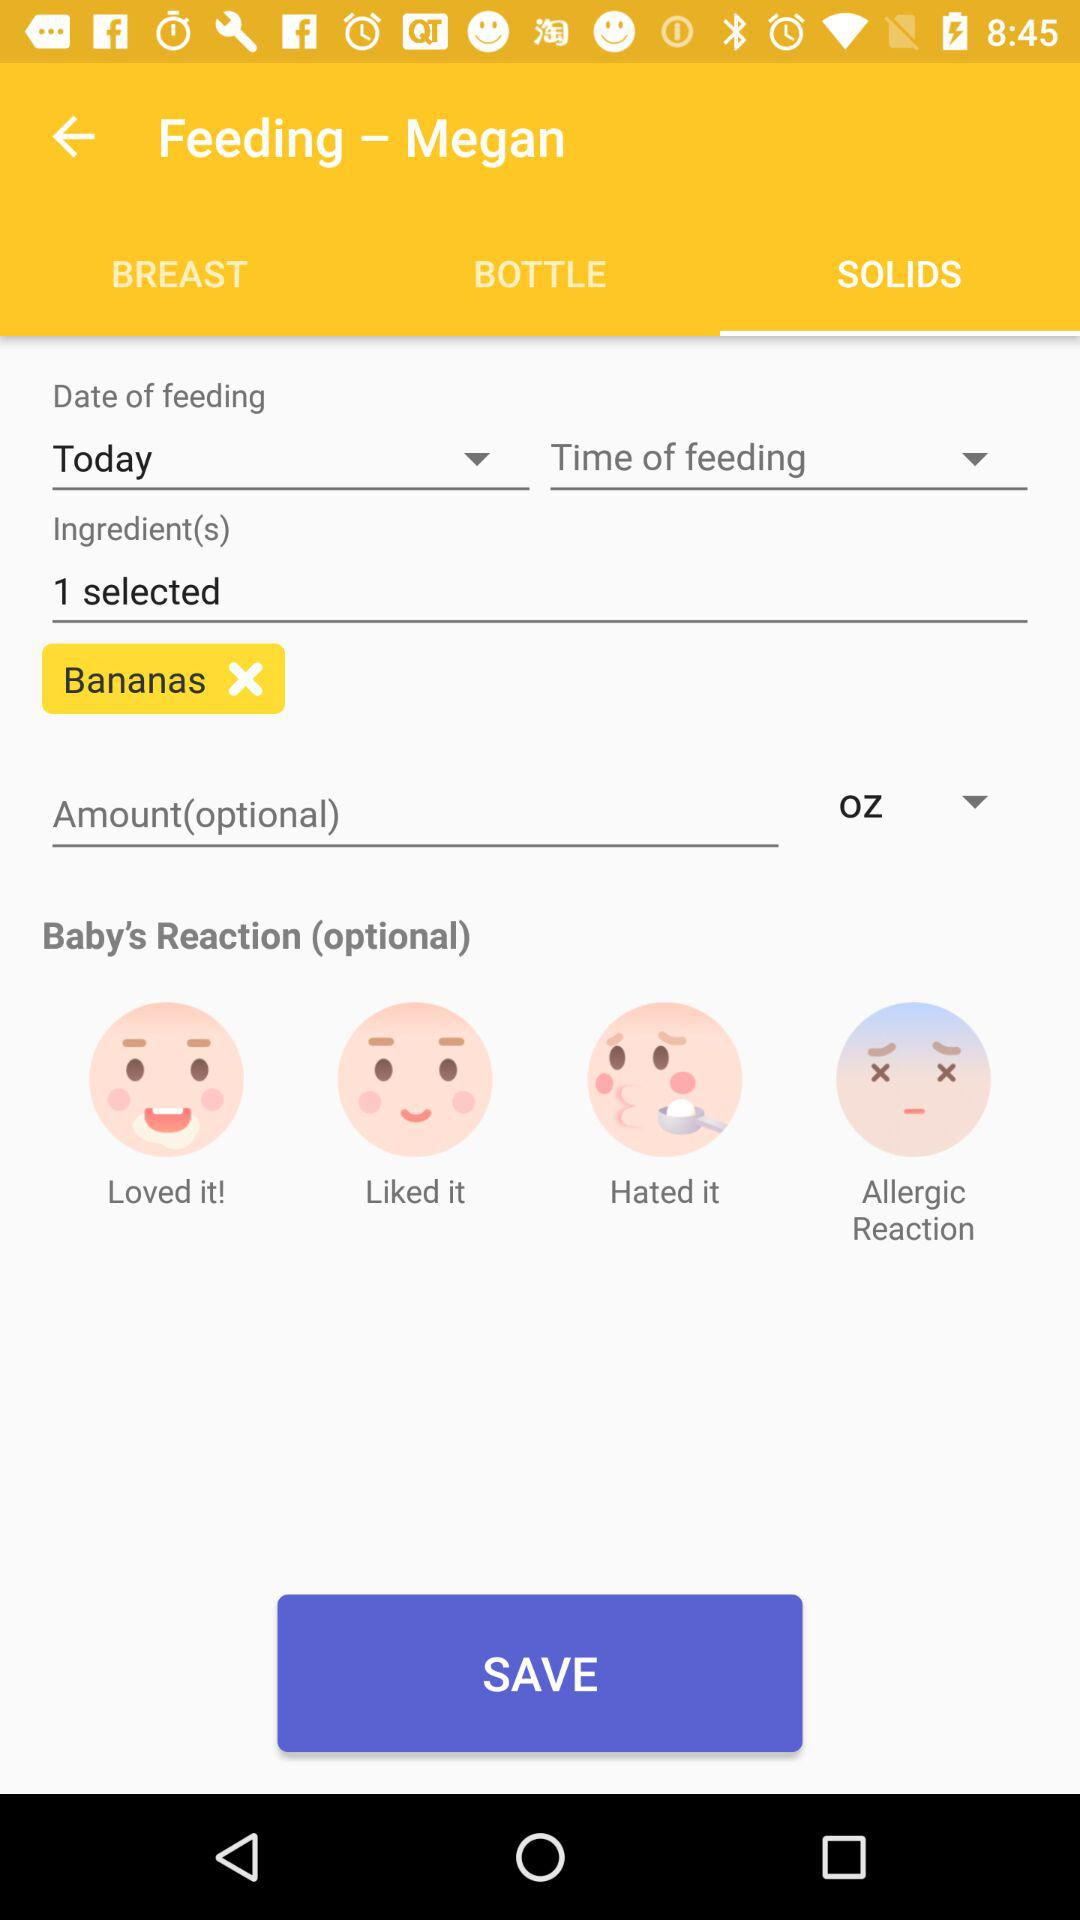How many ingredient options are there?
Answer the question using a single word or phrase. 1 